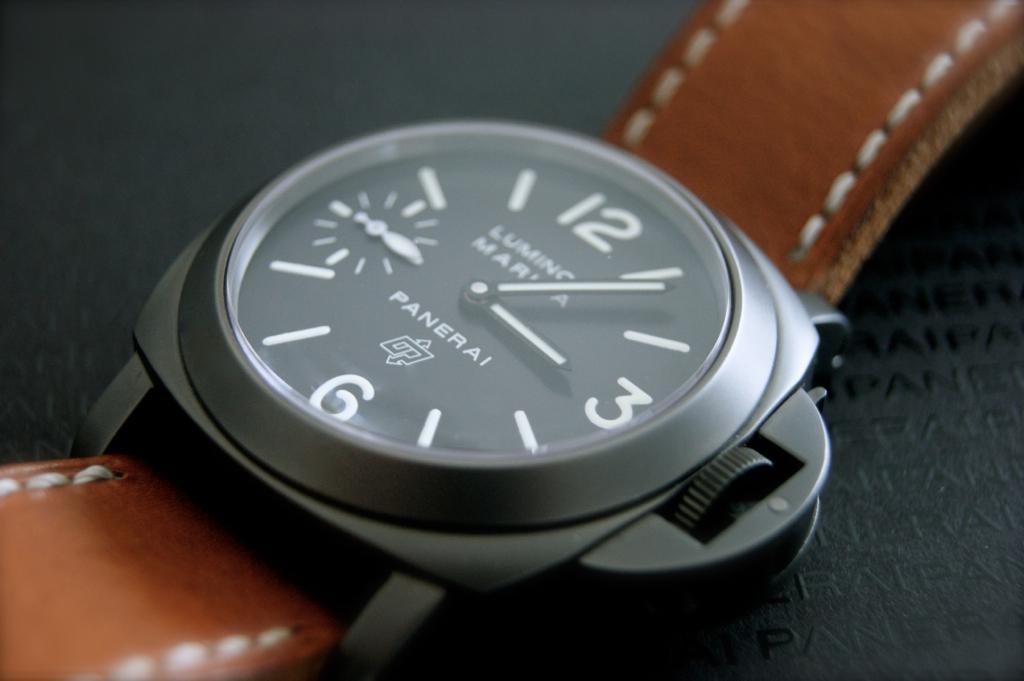What time is on the watch?
Keep it short and to the point. 3:06. What brand is the watch?
Offer a very short reply. Panerai. 